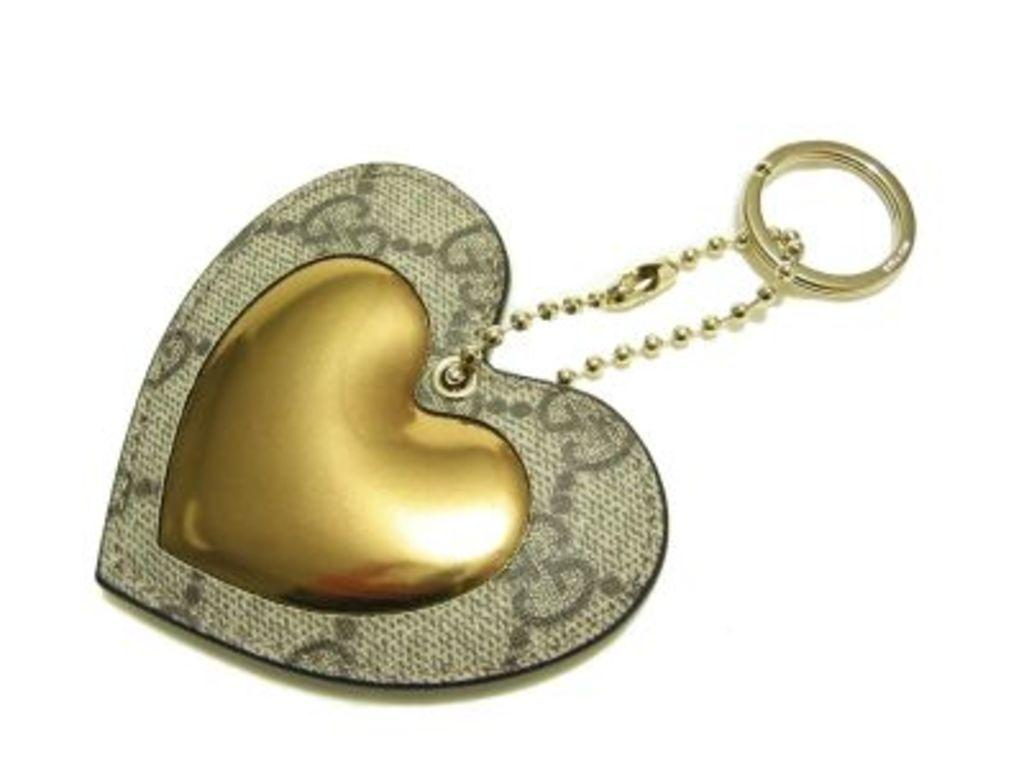What is the main object in the image? There is a heart-shaped locket in the image. What color is the background of the image? The background of the image is white. How many snails can be seen crawling on the land in the image? There are no snails or land present in the image; it features a heart-shaped locket against a white background. 